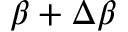Convert formula to latex. <formula><loc_0><loc_0><loc_500><loc_500>\beta + \Delta \beta</formula> 